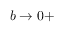Convert formula to latex. <formula><loc_0><loc_0><loc_500><loc_500>\begin{array} { r } { b \rightarrow 0 + } \end{array}</formula> 